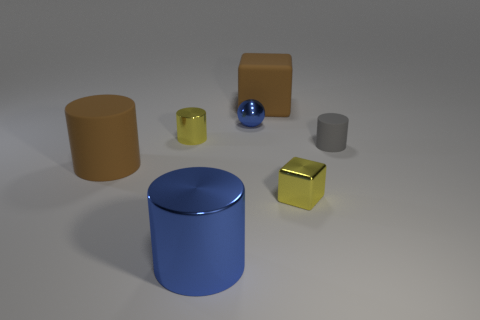There is a cylinder that is the same color as the metallic sphere; what material is it?
Your answer should be compact. Metal. Are there any shiny cylinders behind the blue thing that is behind the tiny yellow metal cylinder?
Offer a terse response. No. Is the color of the big metal cylinder the same as the metal thing that is behind the yellow cylinder?
Offer a very short reply. Yes. Is there a block that has the same material as the tiny blue thing?
Provide a succinct answer. Yes. How many small metallic objects are there?
Your answer should be compact. 3. There is a big brown thing in front of the yellow thing behind the brown cylinder; what is it made of?
Keep it short and to the point. Rubber. There is a large block that is made of the same material as the small gray thing; what is its color?
Your answer should be very brief. Brown. What shape is the big object that is the same color as the shiny sphere?
Make the answer very short. Cylinder. There is a cylinder behind the gray cylinder; does it have the same size as the brown object that is on the right side of the big blue cylinder?
Keep it short and to the point. No. How many cylinders are either yellow objects or blue shiny things?
Provide a succinct answer. 2. 